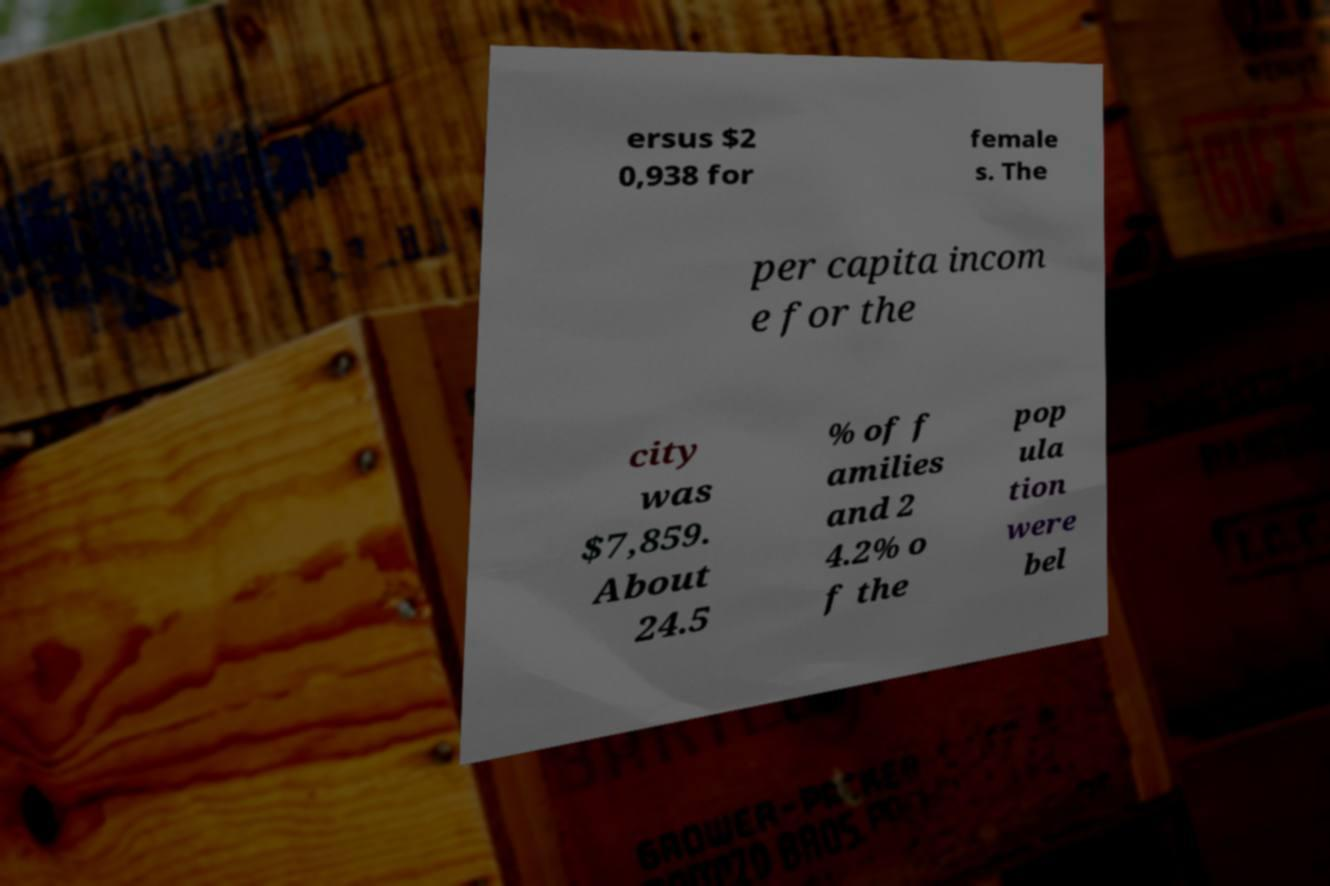There's text embedded in this image that I need extracted. Can you transcribe it verbatim? ersus $2 0,938 for female s. The per capita incom e for the city was $7,859. About 24.5 % of f amilies and 2 4.2% o f the pop ula tion were bel 